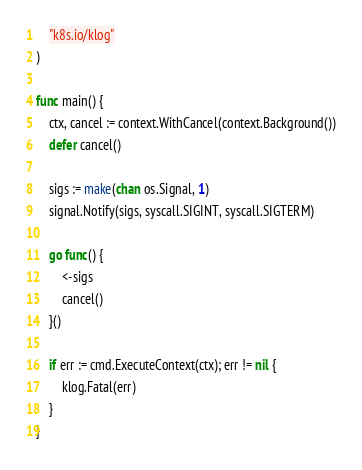<code> <loc_0><loc_0><loc_500><loc_500><_Go_>	"k8s.io/klog"
)

func main() {
	ctx, cancel := context.WithCancel(context.Background())
	defer cancel()

	sigs := make(chan os.Signal, 1)
	signal.Notify(sigs, syscall.SIGINT, syscall.SIGTERM)

	go func() {
		<-sigs
		cancel()
	}()

	if err := cmd.ExecuteContext(ctx); err != nil {
		klog.Fatal(err)
	}
}
</code> 